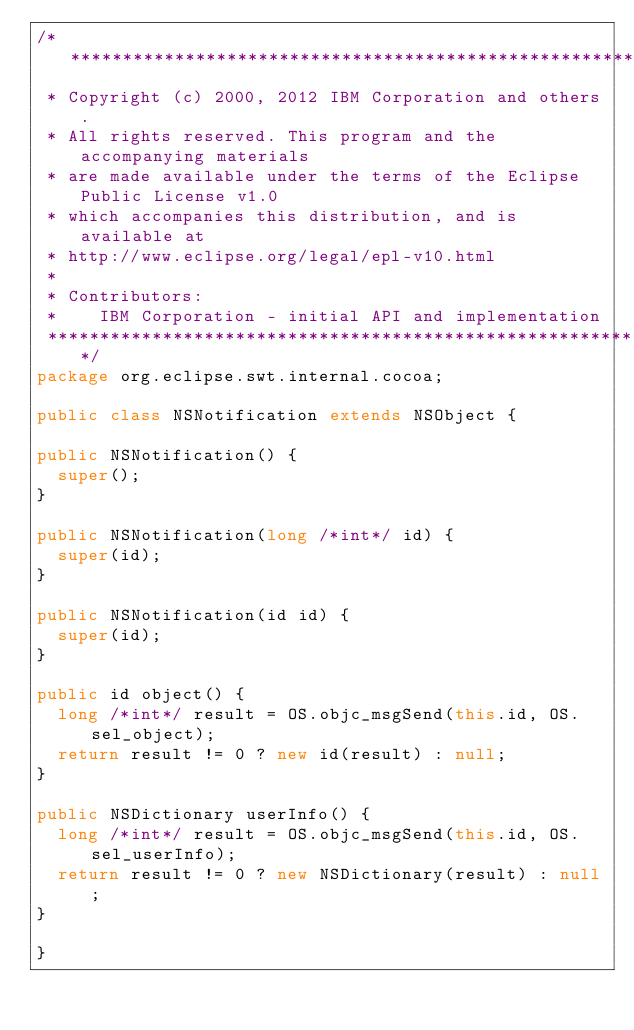<code> <loc_0><loc_0><loc_500><loc_500><_Java_>/*******************************************************************************
 * Copyright (c) 2000, 2012 IBM Corporation and others.
 * All rights reserved. This program and the accompanying materials
 * are made available under the terms of the Eclipse Public License v1.0
 * which accompanies this distribution, and is available at
 * http://www.eclipse.org/legal/epl-v10.html
 *
 * Contributors:
 *    IBM Corporation - initial API and implementation
 *******************************************************************************/
package org.eclipse.swt.internal.cocoa;

public class NSNotification extends NSObject {

public NSNotification() {
	super();
}

public NSNotification(long /*int*/ id) {
	super(id);
}

public NSNotification(id id) {
	super(id);
}

public id object() {
	long /*int*/ result = OS.objc_msgSend(this.id, OS.sel_object);
	return result != 0 ? new id(result) : null;
}

public NSDictionary userInfo() {
	long /*int*/ result = OS.objc_msgSend(this.id, OS.sel_userInfo);
	return result != 0 ? new NSDictionary(result) : null;
}

}
</code> 